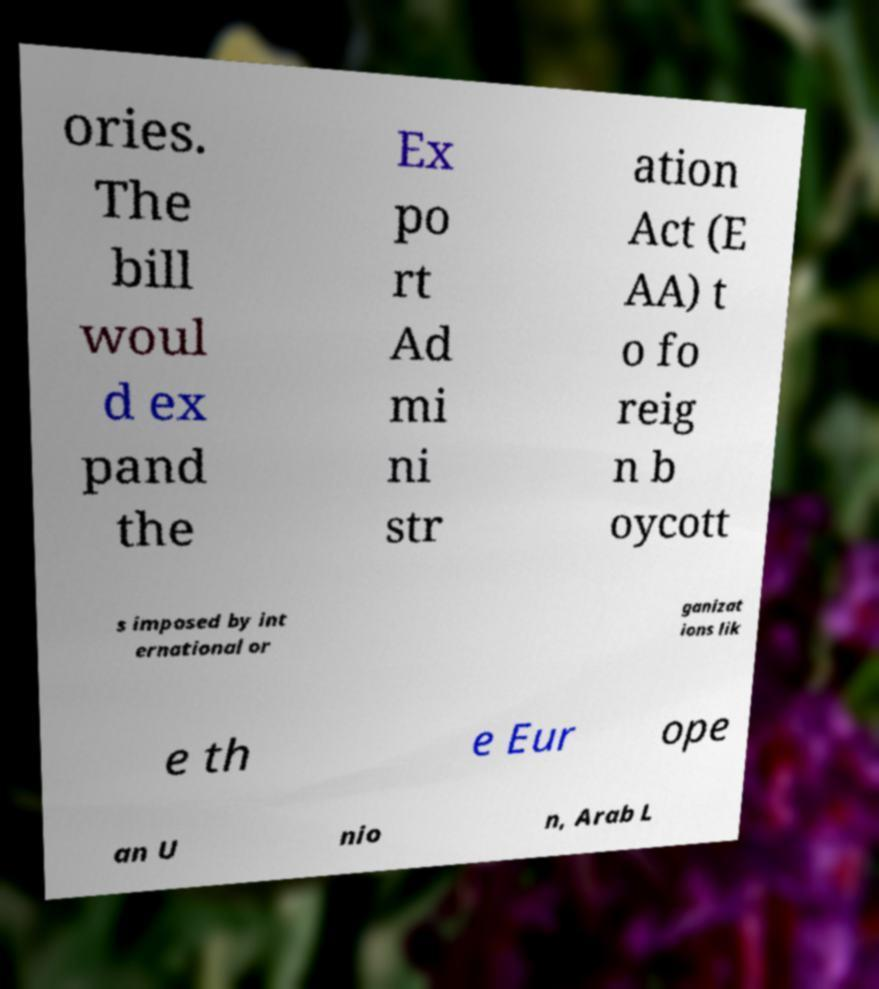What messages or text are displayed in this image? I need them in a readable, typed format. ories. The bill woul d ex pand the Ex po rt Ad mi ni str ation Act (E AA) t o fo reig n b oycott s imposed by int ernational or ganizat ions lik e th e Eur ope an U nio n, Arab L 